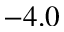Convert formula to latex. <formula><loc_0><loc_0><loc_500><loc_500>- 4 . 0</formula> 